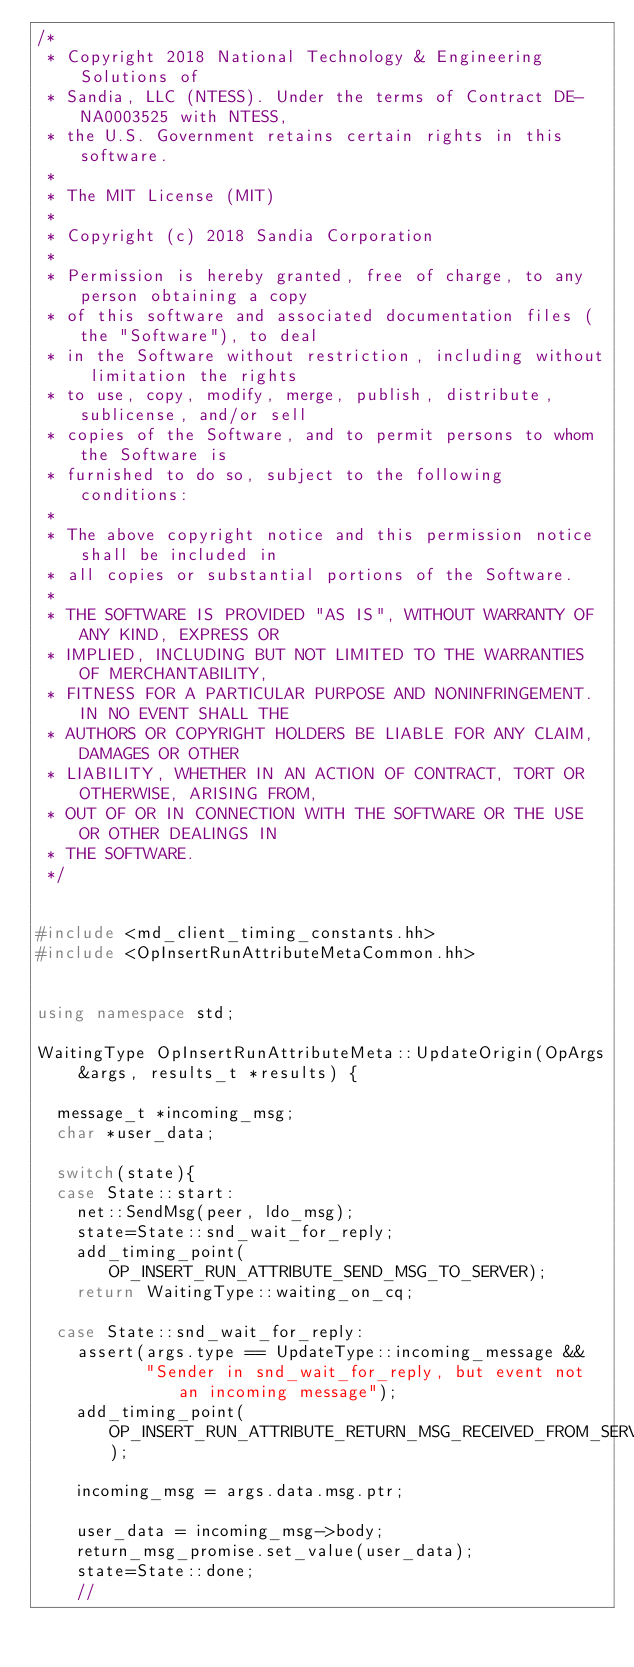Convert code to text. <code><loc_0><loc_0><loc_500><loc_500><_C++_>/* 
 * Copyright 2018 National Technology & Engineering Solutions of
 * Sandia, LLC (NTESS). Under the terms of Contract DE-NA0003525 with NTESS,
 * the U.S. Government retains certain rights in this software.
 *
 * The MIT License (MIT)
 * 
 * Copyright (c) 2018 Sandia Corporation
 * 
 * Permission is hereby granted, free of charge, to any person obtaining a copy
 * of this software and associated documentation files (the "Software"), to deal
 * in the Software without restriction, including without limitation the rights
 * to use, copy, modify, merge, publish, distribute, sublicense, and/or sell
 * copies of the Software, and to permit persons to whom the Software is
 * furnished to do so, subject to the following conditions:
 * 
 * The above copyright notice and this permission notice shall be included in
 * all copies or substantial portions of the Software.
 * 
 * THE SOFTWARE IS PROVIDED "AS IS", WITHOUT WARRANTY OF ANY KIND, EXPRESS OR
 * IMPLIED, INCLUDING BUT NOT LIMITED TO THE WARRANTIES OF MERCHANTABILITY,
 * FITNESS FOR A PARTICULAR PURPOSE AND NONINFRINGEMENT. IN NO EVENT SHALL THE
 * AUTHORS OR COPYRIGHT HOLDERS BE LIABLE FOR ANY CLAIM, DAMAGES OR OTHER
 * LIABILITY, WHETHER IN AN ACTION OF CONTRACT, TORT OR OTHERWISE, ARISING FROM,
 * OUT OF OR IN CONNECTION WITH THE SOFTWARE OR THE USE OR OTHER DEALINGS IN
 * THE SOFTWARE.
 */


#include <md_client_timing_constants.hh>
#include <OpInsertRunAttributeMetaCommon.hh>


using namespace std;

WaitingType OpInsertRunAttributeMeta::UpdateOrigin(OpArgs &args, results_t *results) {

  message_t *incoming_msg;
  char *user_data;

  switch(state){
  case State::start:
    net::SendMsg(peer, ldo_msg);
    state=State::snd_wait_for_reply;
    add_timing_point(OP_INSERT_RUN_ATTRIBUTE_SEND_MSG_TO_SERVER);
    return WaitingType::waiting_on_cq;

  case State::snd_wait_for_reply:
    assert(args.type == UpdateType::incoming_message &&
           "Sender in snd_wait_for_reply, but event not an incoming message");
    add_timing_point(OP_INSERT_RUN_ATTRIBUTE_RETURN_MSG_RECEIVED_FROM_SERVER); 
    
    incoming_msg = args.data.msg.ptr;

    user_data = incoming_msg->body;
    return_msg_promise.set_value(user_data);
    state=State::done;
    // </code> 